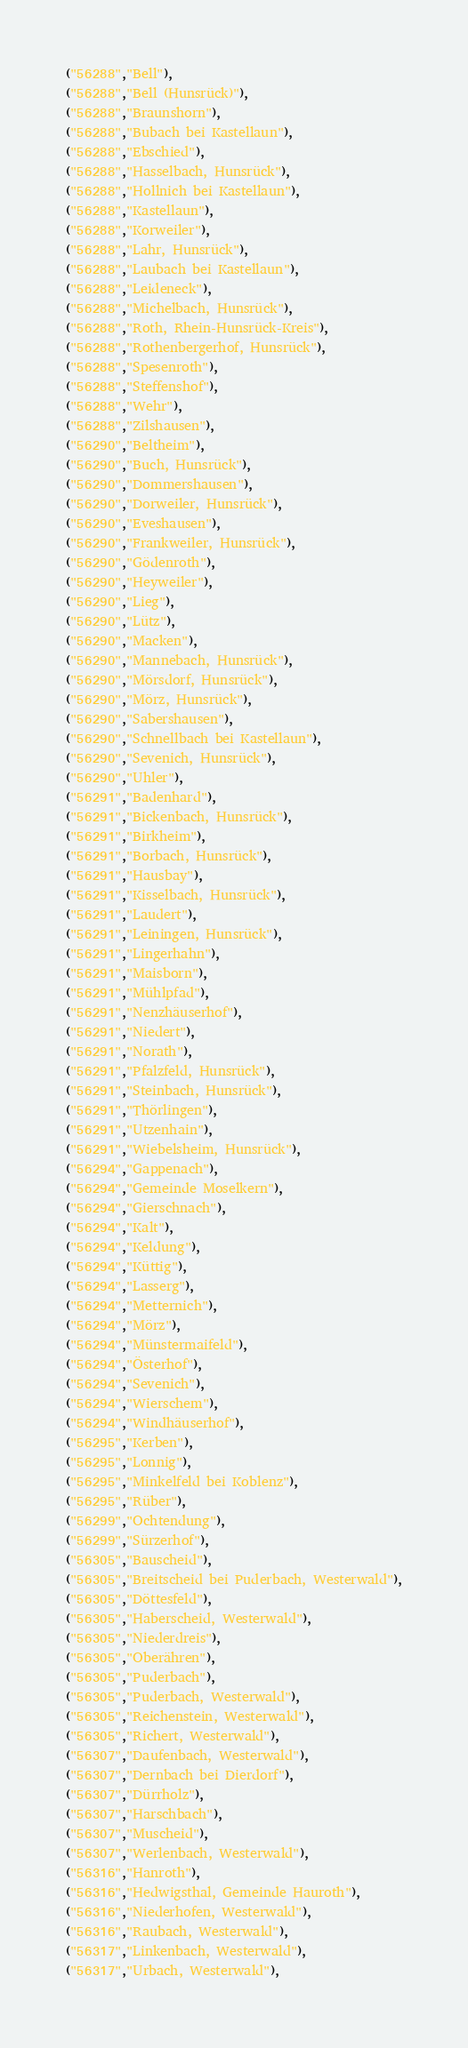Convert code to text. <code><loc_0><loc_0><loc_500><loc_500><_SQL_>("56288","Bell"),
("56288","Bell (Hunsrück)"),
("56288","Braunshorn"),
("56288","Bubach bei Kastellaun"),
("56288","Ebschied"),
("56288","Hasselbach, Hunsrück"),
("56288","Hollnich bei Kastellaun"),
("56288","Kastellaun"),
("56288","Korweiler"),
("56288","Lahr, Hunsrück"),
("56288","Laubach bei Kastellaun"),
("56288","Leideneck"),
("56288","Michelbach, Hunsrück"),
("56288","Roth, Rhein-Hunsrück-Kreis"),
("56288","Rothenbergerhof, Hunsrück"),
("56288","Spesenroth"),
("56288","Steffenshof"),
("56288","Wehr"),
("56288","Zilshausen"),
("56290","Beltheim"),
("56290","Buch, Hunsrück"),
("56290","Dommershausen"),
("56290","Dorweiler, Hunsrück"),
("56290","Eveshausen"),
("56290","Frankweiler, Hunsrück"),
("56290","Gödenroth"),
("56290","Heyweiler"),
("56290","Lieg"),
("56290","Lütz"),
("56290","Macken"),
("56290","Mannebach, Hunsrück"),
("56290","Mörsdorf, Hunsrück"),
("56290","Mörz, Hunsrück"),
("56290","Sabershausen"),
("56290","Schnellbach bei Kastellaun"),
("56290","Sevenich, Hunsrück"),
("56290","Uhler"),
("56291","Badenhard"),
("56291","Bickenbach, Hunsrück"),
("56291","Birkheim"),
("56291","Borbach, Hunsrück"),
("56291","Hausbay"),
("56291","Kisselbach, Hunsrück"),
("56291","Laudert"),
("56291","Leiningen, Hunsrück"),
("56291","Lingerhahn"),
("56291","Maisborn"),
("56291","Mühlpfad"),
("56291","Nenzhäuserhof"),
("56291","Niedert"),
("56291","Norath"),
("56291","Pfalzfeld, Hunsrück"),
("56291","Steinbach, Hunsrück"),
("56291","Thörlingen"),
("56291","Utzenhain"),
("56291","Wiebelsheim, Hunsrück"),
("56294","Gappenach"),
("56294","Gemeinde Moselkern"),
("56294","Gierschnach"),
("56294","Kalt"),
("56294","Keldung"),
("56294","Küttig"),
("56294","Lasserg"),
("56294","Metternich"),
("56294","Mörz"),
("56294","Münstermaifeld"),
("56294","Österhof"),
("56294","Sevenich"),
("56294","Wierschem"),
("56294","Windhäuserhof"),
("56295","Kerben"),
("56295","Lonnig"),
("56295","Minkelfeld bei Koblenz"),
("56295","Rüber"),
("56299","Ochtendung"),
("56299","Sürzerhof"),
("56305","Bauscheid"),
("56305","Breitscheid bei Puderbach, Westerwald"),
("56305","Döttesfeld"),
("56305","Haberscheid, Westerwald"),
("56305","Niederdreis"),
("56305","Oberähren"),
("56305","Puderbach"),
("56305","Puderbach, Westerwald"),
("56305","Reichenstein, Westerwald"),
("56305","Richert, Westerwald"),
("56307","Daufenbach, Westerwald"),
("56307","Dernbach bei Dierdorf"),
("56307","Dürrholz"),
("56307","Harschbach"),
("56307","Muscheid"),
("56307","Werlenbach, Westerwald"),
("56316","Hanroth"),
("56316","Hedwigsthal, Gemeinde Hauroth"),
("56316","Niederhofen, Westerwald"),
("56316","Raubach, Westerwald"),
("56317","Linkenbach, Westerwald"),
("56317","Urbach, Westerwald"),</code> 